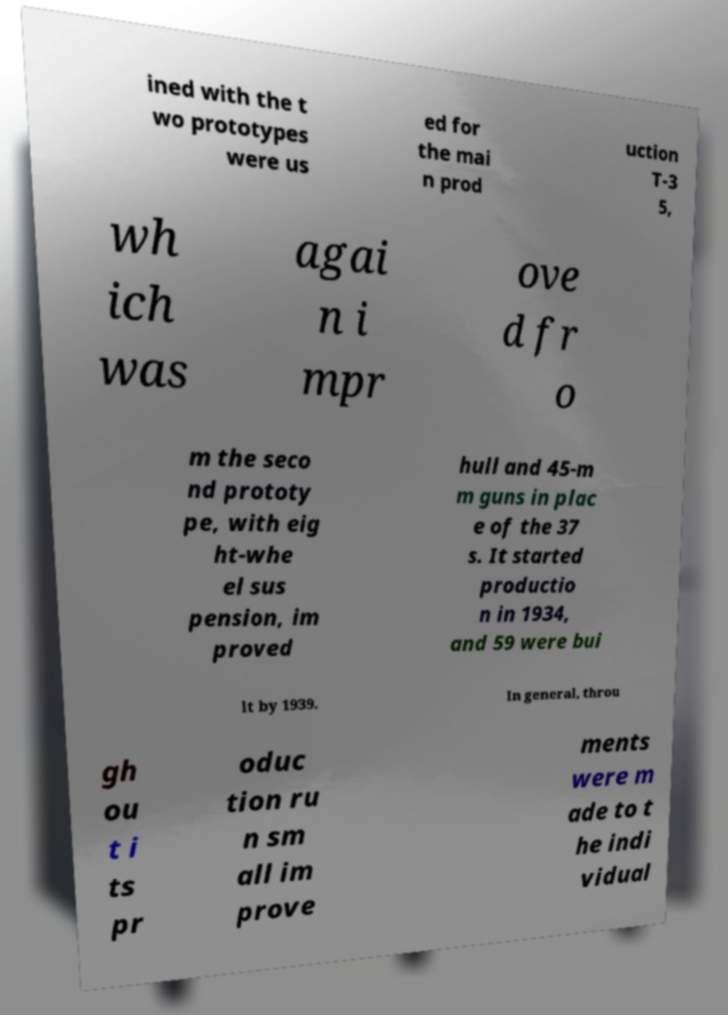What messages or text are displayed in this image? I need them in a readable, typed format. ined with the t wo prototypes were us ed for the mai n prod uction T-3 5, wh ich was agai n i mpr ove d fr o m the seco nd prototy pe, with eig ht-whe el sus pension, im proved hull and 45-m m guns in plac e of the 37 s. It started productio n in 1934, and 59 were bui lt by 1939. In general, throu gh ou t i ts pr oduc tion ru n sm all im prove ments were m ade to t he indi vidual 